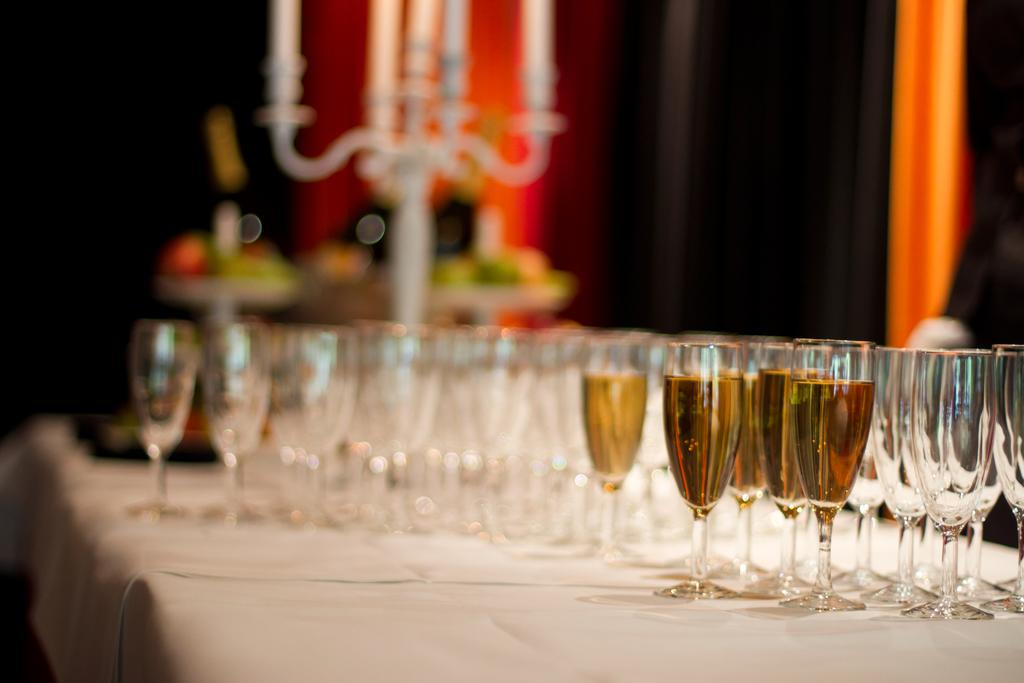What type of beverage is in the glasses on the table? There are glasses of wine on the table. Are there any glasses without any beverage in them? Yes, there are empty glasses on the table. What can be seen in the background of the image? There are candles and candle stands in the background. Can you describe any other objects in the background? There are other unspecified objects in the background. What type of key is used to open the wine bottles in the image? There are no keys present in the image, and wine bottles typically do not require keys to open. Can you see any grapes in the image? There is no mention of grapes in the image, and they are not visible in the provided facts. Is there a donkey in the image? There is no mention of a donkey in the image or the provided facts. 